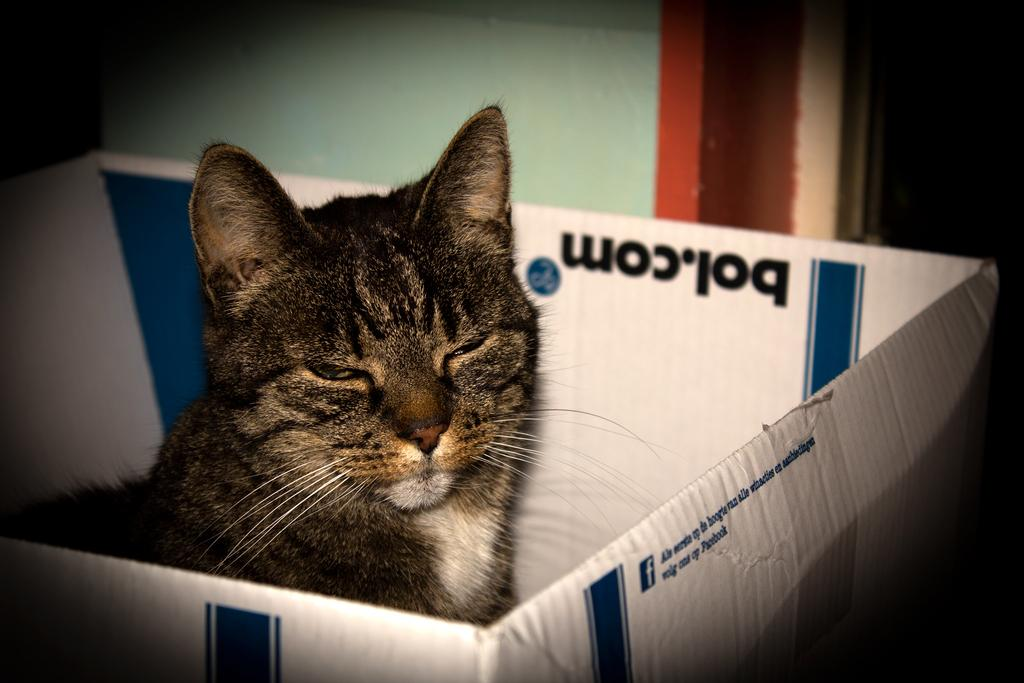What animal is present in the image? There is a cat in the image. Where is the cat located in the image? The cat is sitting in a box. What is written or printed on the box? There is text printed on the box. How many hands are visible in the image? There are no hands visible in the image. What type of fruit is the cat holding in the image? There is no fruit, such as a banana, present in the image. 